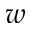<formula> <loc_0><loc_0><loc_500><loc_500>w</formula> 